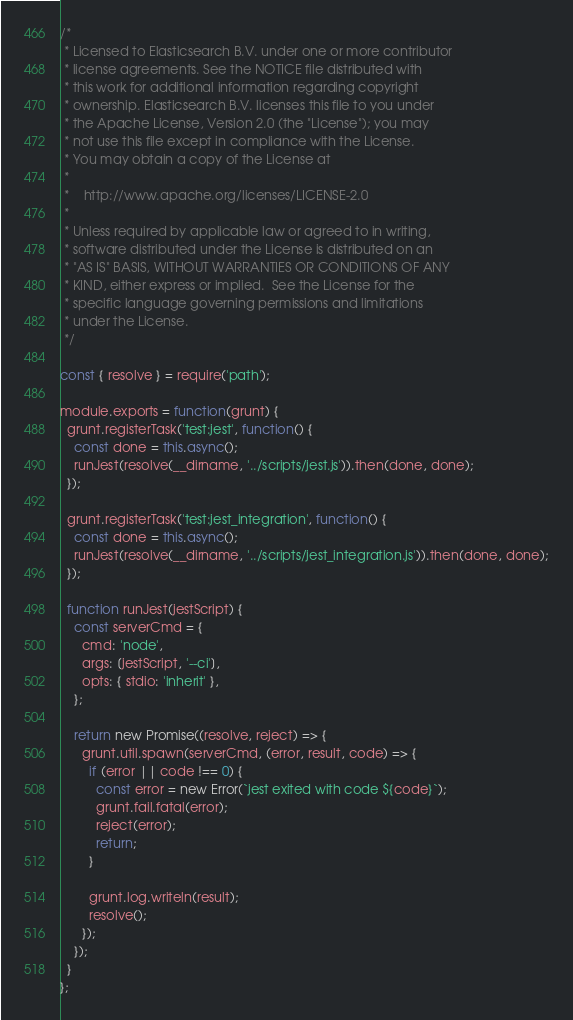Convert code to text. <code><loc_0><loc_0><loc_500><loc_500><_JavaScript_>/*
 * Licensed to Elasticsearch B.V. under one or more contributor
 * license agreements. See the NOTICE file distributed with
 * this work for additional information regarding copyright
 * ownership. Elasticsearch B.V. licenses this file to you under
 * the Apache License, Version 2.0 (the "License"); you may
 * not use this file except in compliance with the License.
 * You may obtain a copy of the License at
 *
 *    http://www.apache.org/licenses/LICENSE-2.0
 *
 * Unless required by applicable law or agreed to in writing,
 * software distributed under the License is distributed on an
 * "AS IS" BASIS, WITHOUT WARRANTIES OR CONDITIONS OF ANY
 * KIND, either express or implied.  See the License for the
 * specific language governing permissions and limitations
 * under the License.
 */

const { resolve } = require('path');

module.exports = function(grunt) {
  grunt.registerTask('test:jest', function() {
    const done = this.async();
    runJest(resolve(__dirname, '../scripts/jest.js')).then(done, done);
  });

  grunt.registerTask('test:jest_integration', function() {
    const done = this.async();
    runJest(resolve(__dirname, '../scripts/jest_integration.js')).then(done, done);
  });

  function runJest(jestScript) {
    const serverCmd = {
      cmd: 'node',
      args: [jestScript, '--ci'],
      opts: { stdio: 'inherit' },
    };

    return new Promise((resolve, reject) => {
      grunt.util.spawn(serverCmd, (error, result, code) => {
        if (error || code !== 0) {
          const error = new Error(`jest exited with code ${code}`);
          grunt.fail.fatal(error);
          reject(error);
          return;
        }

        grunt.log.writeln(result);
        resolve();
      });
    });
  }
};
</code> 